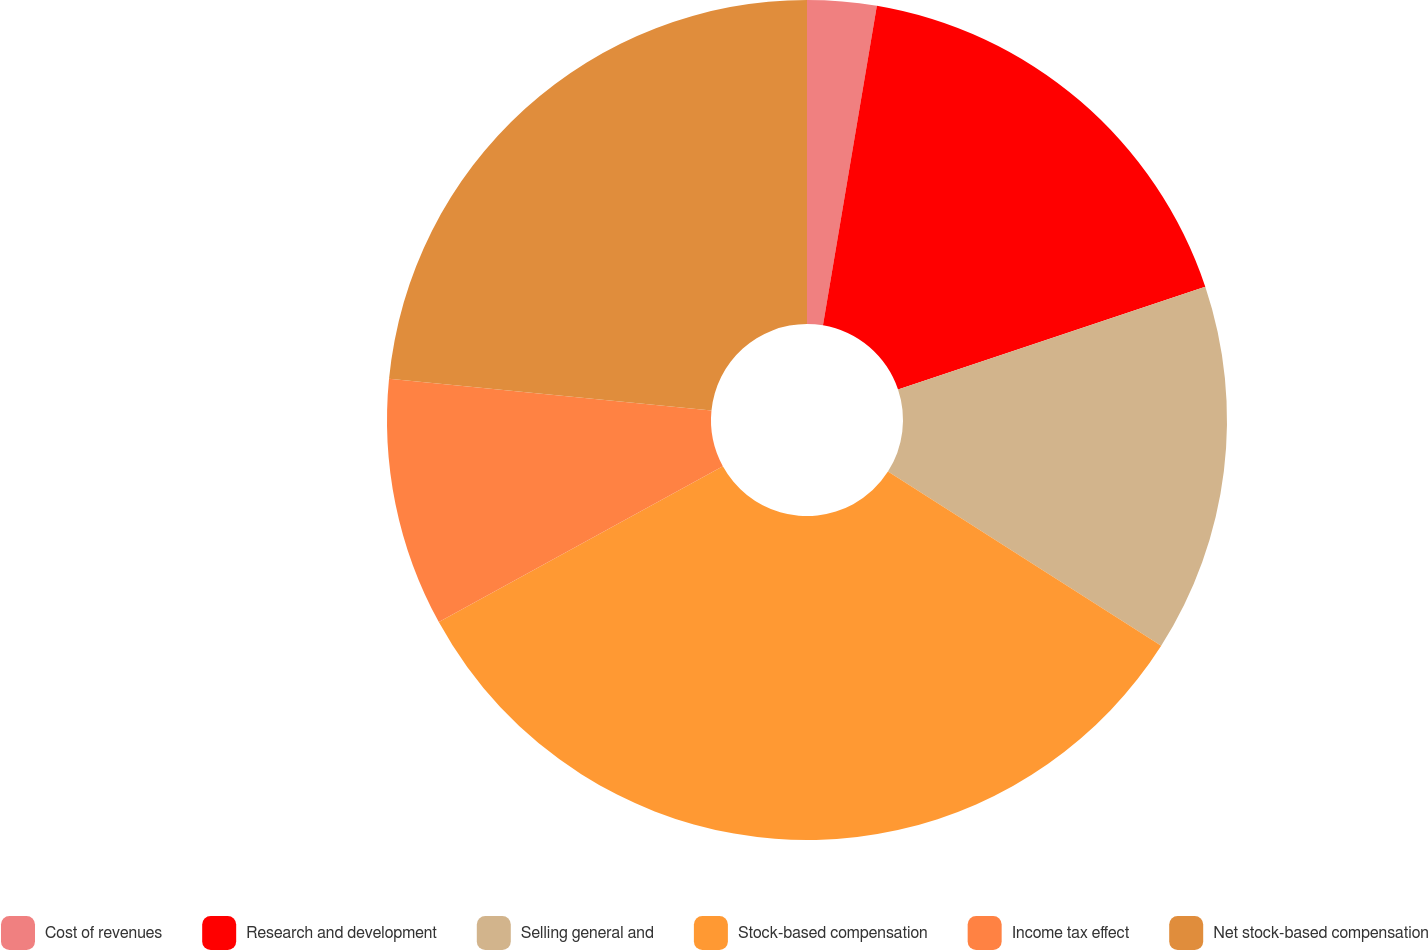<chart> <loc_0><loc_0><loc_500><loc_500><pie_chart><fcel>Cost of revenues<fcel>Research and development<fcel>Selling general and<fcel>Stock-based compensation<fcel>Income tax effect<fcel>Net stock-based compensation<nl><fcel>2.66%<fcel>17.2%<fcel>14.17%<fcel>32.98%<fcel>9.56%<fcel>23.43%<nl></chart> 